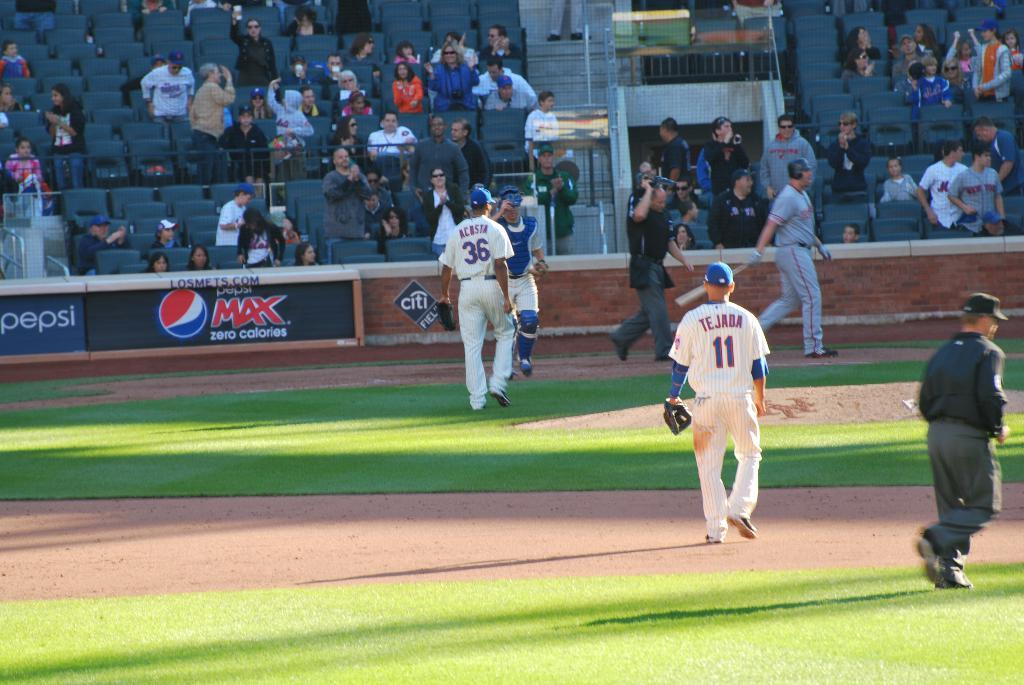<image>
Render a clear and concise summary of the photo. Baseball players number 36 and 11 on a field with Pepsi MAX banners on wall 